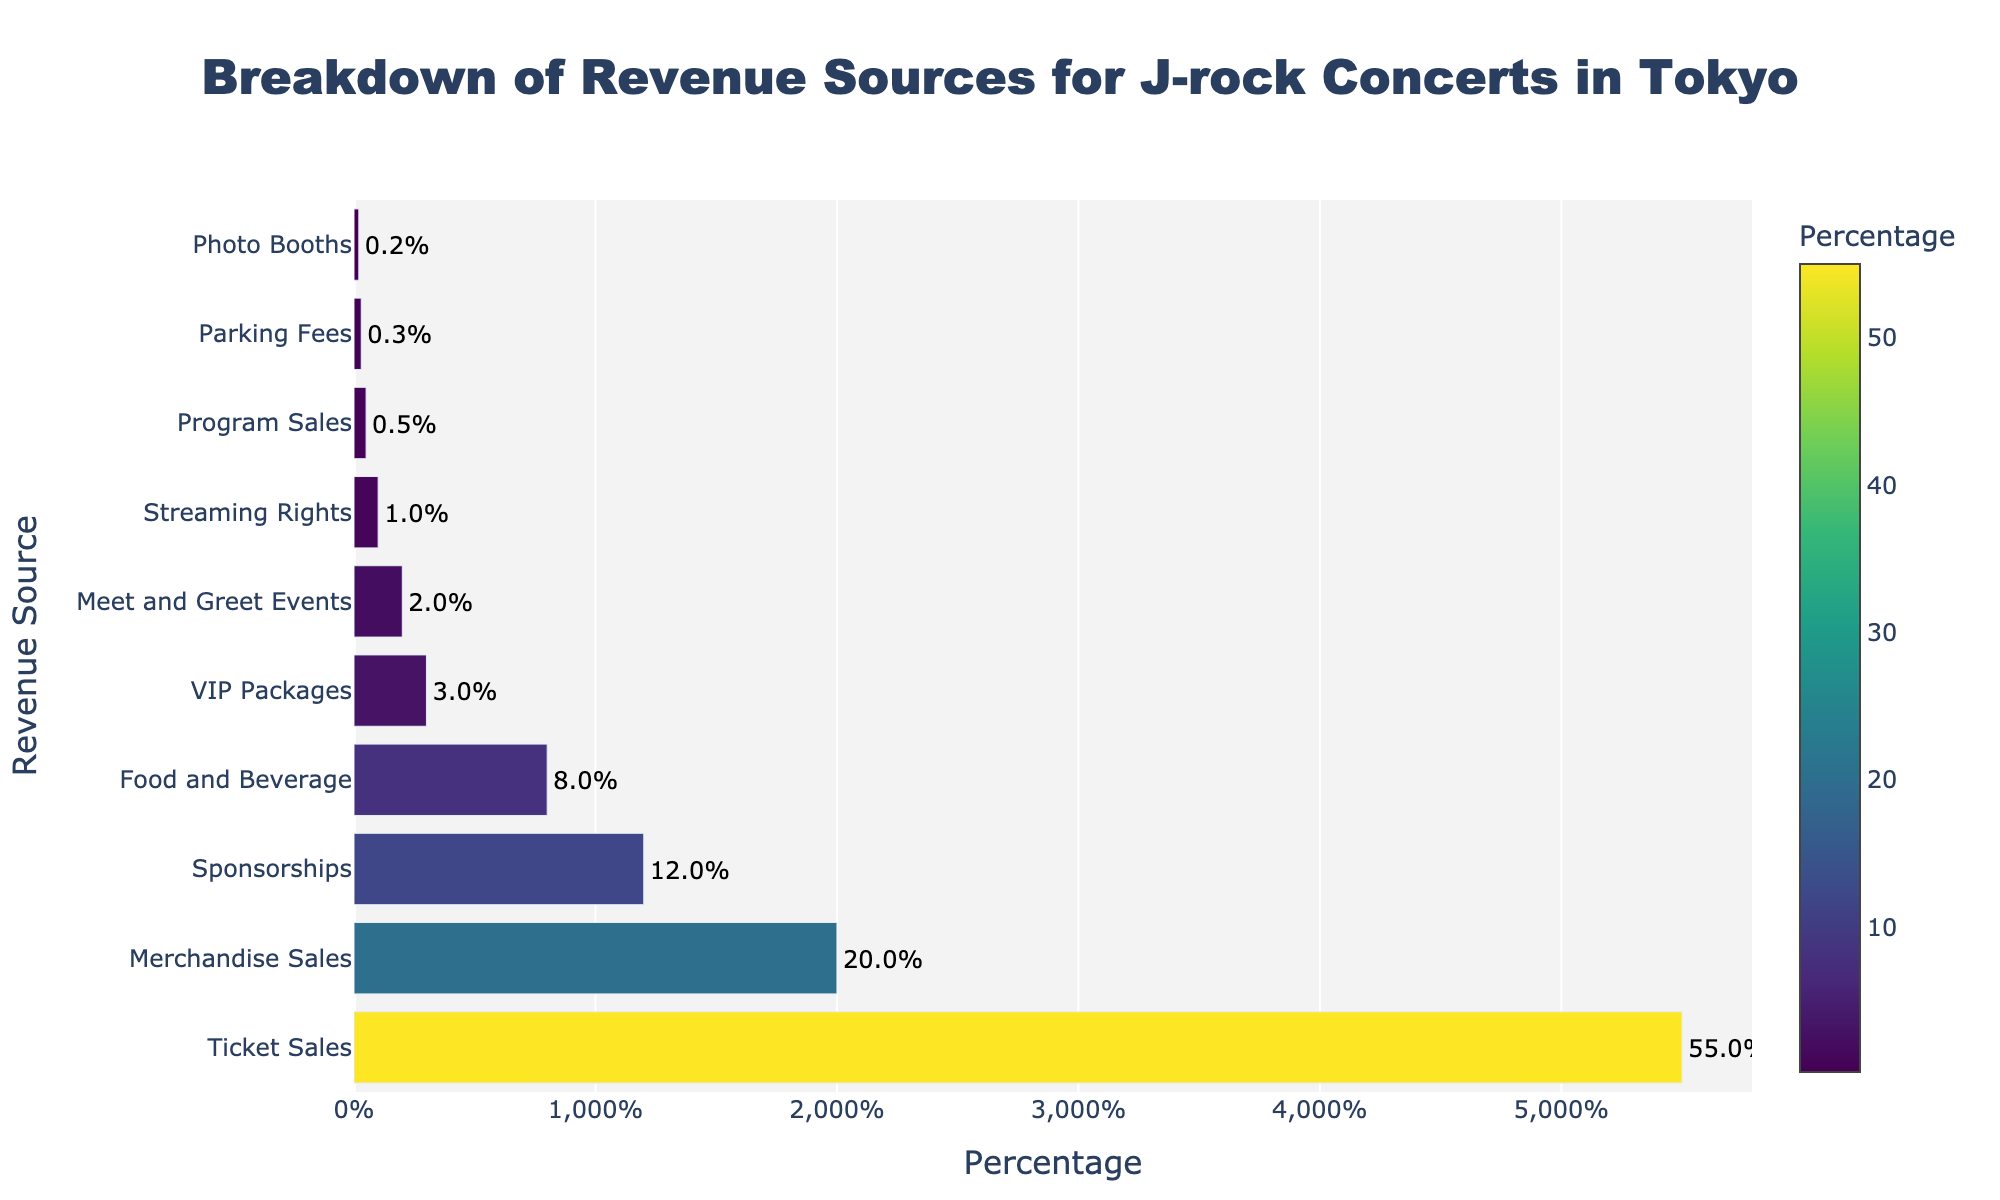What’s the total percentage of revenue that comes from Ticket Sales, Merchandise Sales, and Sponsorships? To find the total percentage, sum the percentages of Ticket Sales (55), Merchandise Sales (20), and Sponsorships (12): 55 + 20 + 12 = 87
Answer: 87% Which revenue source contributes more, VIP Packages or Meet and Greet Events? Compare the percentages of VIP Packages (3) and Meet and Greet Events (2). Since 3 > 2, VIP Packages contributes more.
Answer: VIP Packages How much higher is the percentage of revenue from Ticket Sales compared to Food and Beverage? Subtract the percentage of Food and Beverage (8) from Ticket Sales (55): 55 - 8 = 47
Answer: 47% Which revenue source has the lowest percentage contribution? Identify the revenue source with the smallest percentage. Photo Booths have the lowest at 0.2%.
Answer: Photo Booths What is the combined percentage of revenue generated by Streaming Rights, Program Sales, and Parking Fees? Add the percentages of Streaming Rights (1), Program Sales (0.5), and Parking Fees (0.3): 1 + 0.5 + 0.3 = 1.8
Answer: 1.8% Is the revenue from Ticket Sales greater than that from Merchandise Sales and Food and Beverage combined? Compare the Ticket Sales percentage (55) with the sum of Merchandise Sales (20) and Food and Beverage (8): 55 compared to 20 + 8 = 28, so 55 > 28.
Answer: Yes What’s the average percentage contribution of the smallest four revenue sources? Identify the four smallest sources by percentages: Photo Booths (0.2), Parking Fees (0.3), Program Sales (0.5), and Streaming Rights (1). Calculate their average: (0.2 + 0.3 + 0.5 + 1) / 4 = 0.5
Answer: 0.5% Which revenue source has a percentage close to Merchandise Sales but lower than it? Identify the revenue source close to but lower than 20% (Merchandise Sales). Sponsorships (12%) is the closest.
Answer: Sponsorships What percentage range do the majority of revenue sources fall within? Observe the percentage values of all revenue sources. Most (6 out of 10) fall within the 0.2% to 12% range.
Answer: 0.2% to 12% 